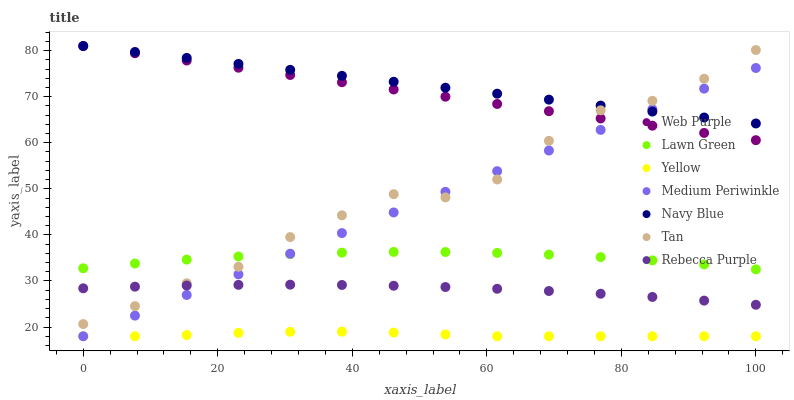Does Yellow have the minimum area under the curve?
Answer yes or no. Yes. Does Navy Blue have the maximum area under the curve?
Answer yes or no. Yes. Does Medium Periwinkle have the minimum area under the curve?
Answer yes or no. No. Does Medium Periwinkle have the maximum area under the curve?
Answer yes or no. No. Is Web Purple the smoothest?
Answer yes or no. Yes. Is Tan the roughest?
Answer yes or no. Yes. Is Navy Blue the smoothest?
Answer yes or no. No. Is Navy Blue the roughest?
Answer yes or no. No. Does Medium Periwinkle have the lowest value?
Answer yes or no. Yes. Does Navy Blue have the lowest value?
Answer yes or no. No. Does Web Purple have the highest value?
Answer yes or no. Yes. Does Medium Periwinkle have the highest value?
Answer yes or no. No. Is Yellow less than Rebecca Purple?
Answer yes or no. Yes. Is Web Purple greater than Rebecca Purple?
Answer yes or no. Yes. Does Web Purple intersect Medium Periwinkle?
Answer yes or no. Yes. Is Web Purple less than Medium Periwinkle?
Answer yes or no. No. Is Web Purple greater than Medium Periwinkle?
Answer yes or no. No. Does Yellow intersect Rebecca Purple?
Answer yes or no. No. 